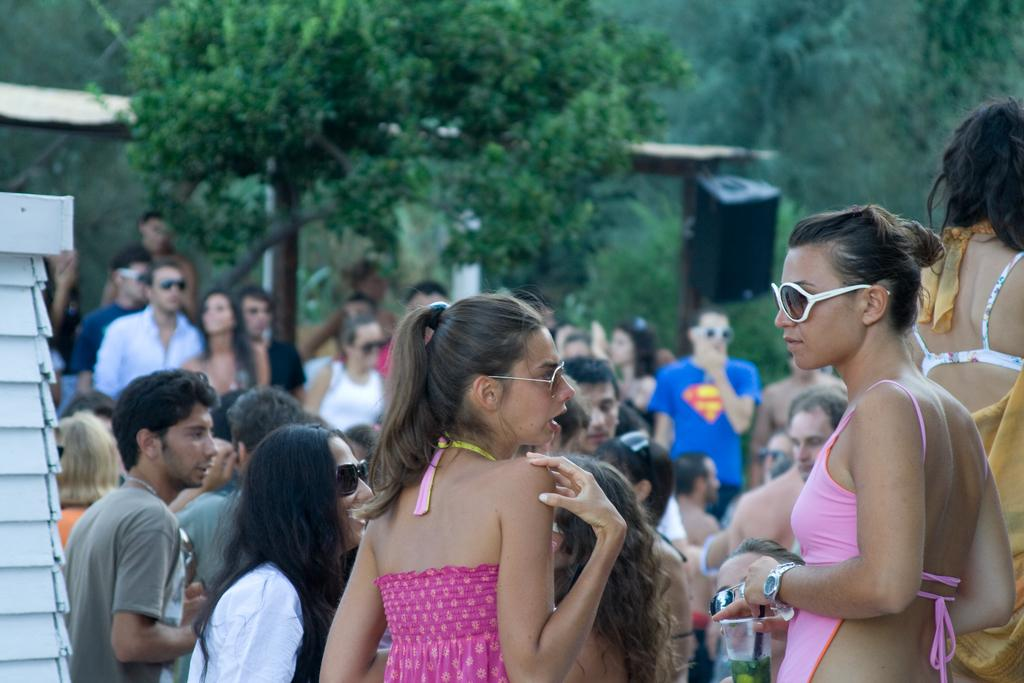How many persons with spectacles can be seen in the image? There are two persons with spectacles in the image. What are the two persons with spectacles doing? The two persons with spectacles are standing. What can be seen in the background of the image? There is a group of people, trees, and a speaker in the background of the image. What type of bubble is being used by the secretary in the image? There is no secretary or bubble present in the image. What type of land is visible in the image? The image does not show any land; it is focused on the two persons with spectacles and the background elements. 